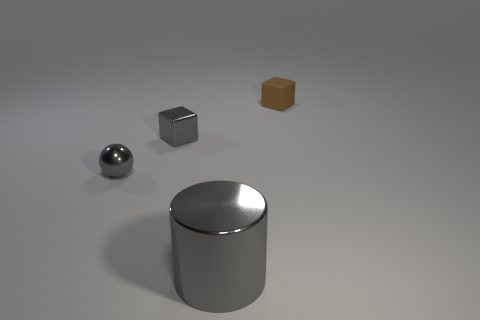Add 2 brown shiny cylinders. How many objects exist? 6 Add 3 rubber objects. How many rubber objects are left? 4 Add 2 tiny spheres. How many tiny spheres exist? 3 Subtract all brown blocks. How many blocks are left? 1 Subtract 1 gray balls. How many objects are left? 3 Subtract all balls. How many objects are left? 3 Subtract 1 blocks. How many blocks are left? 1 Subtract all red cylinders. Subtract all cyan cubes. How many cylinders are left? 1 Subtract all red cylinders. How many blue blocks are left? 0 Subtract all tiny rubber things. Subtract all cyan cylinders. How many objects are left? 3 